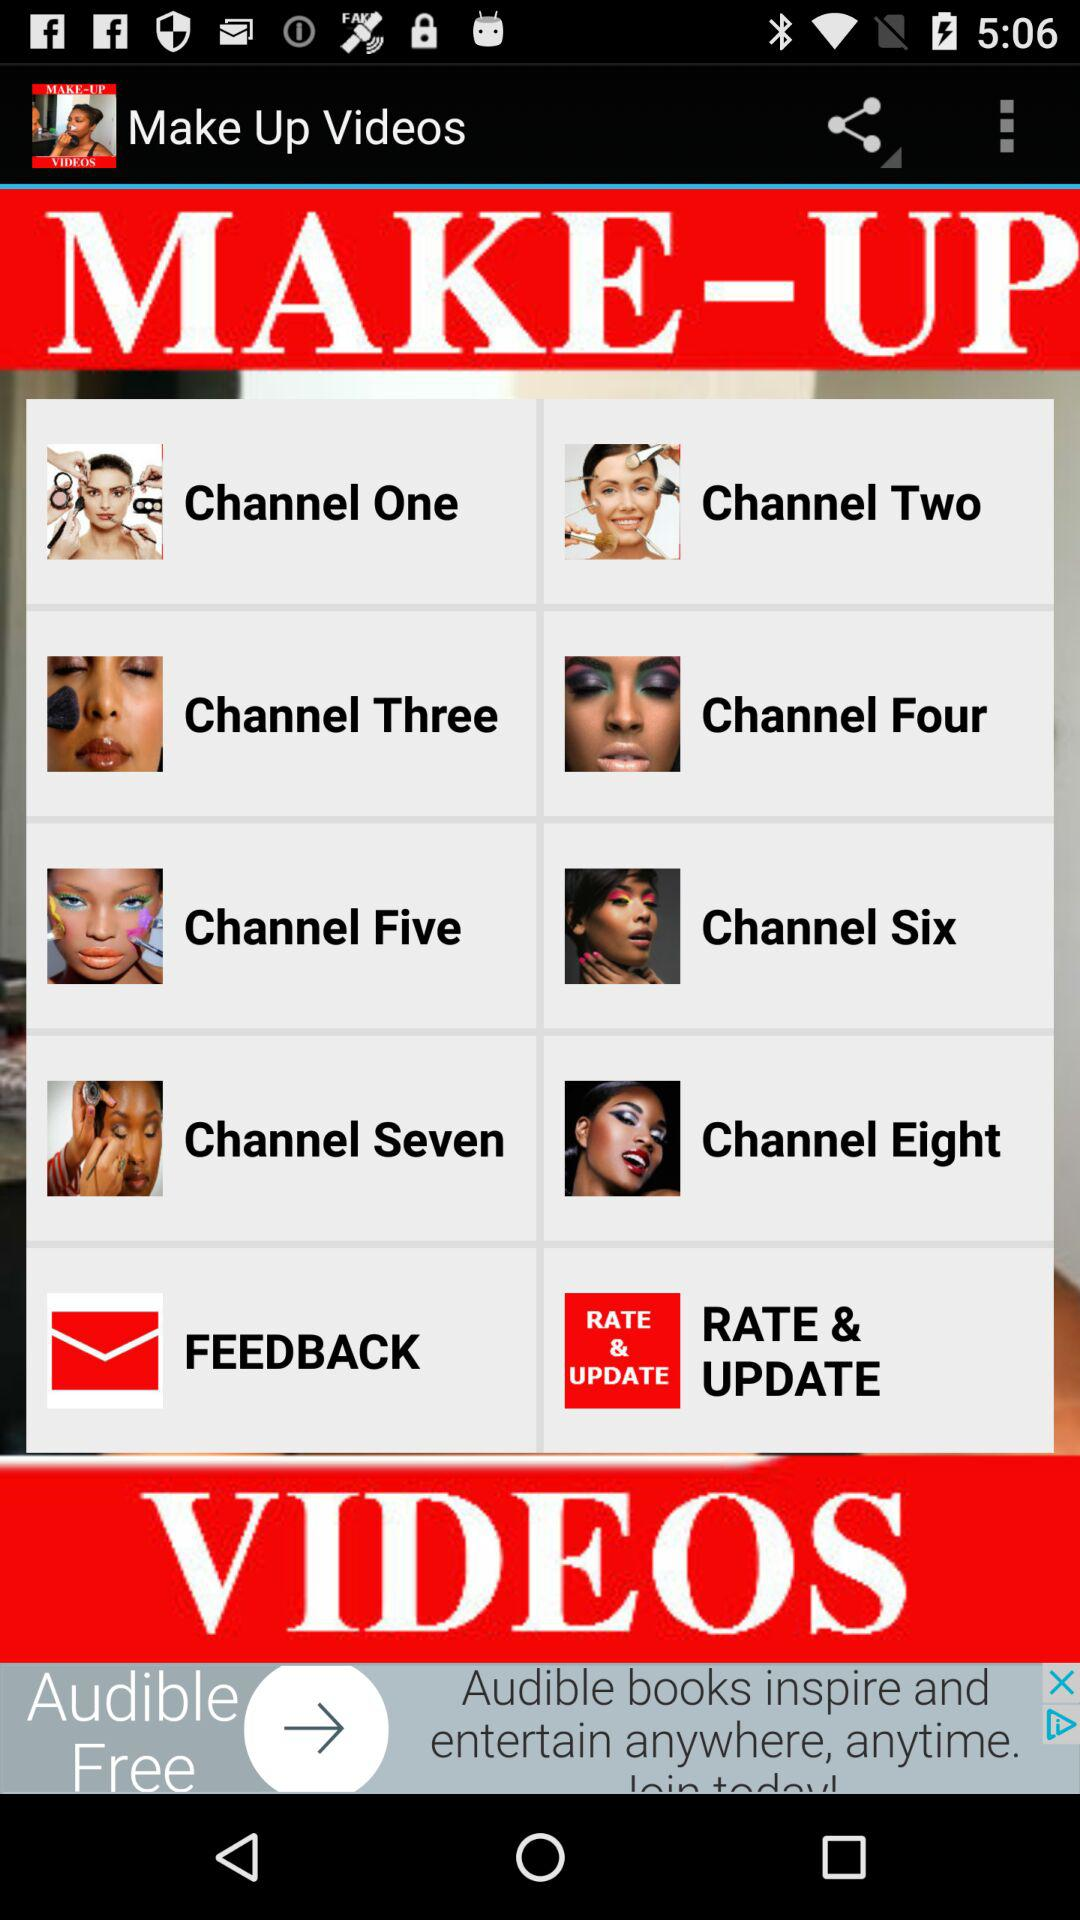How many channels in total are there on this page?
Answer the question using a single word or phrase. 8 